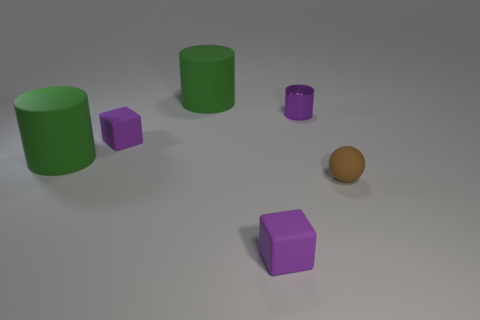Subtract all red balls. Subtract all red blocks. How many balls are left? 1 Add 2 tiny purple blocks. How many objects exist? 8 Subtract all balls. How many objects are left? 5 Add 2 large green matte cylinders. How many large green matte cylinders exist? 4 Subtract 0 yellow balls. How many objects are left? 6 Subtract all tiny yellow shiny spheres. Subtract all purple rubber objects. How many objects are left? 4 Add 5 green things. How many green things are left? 7 